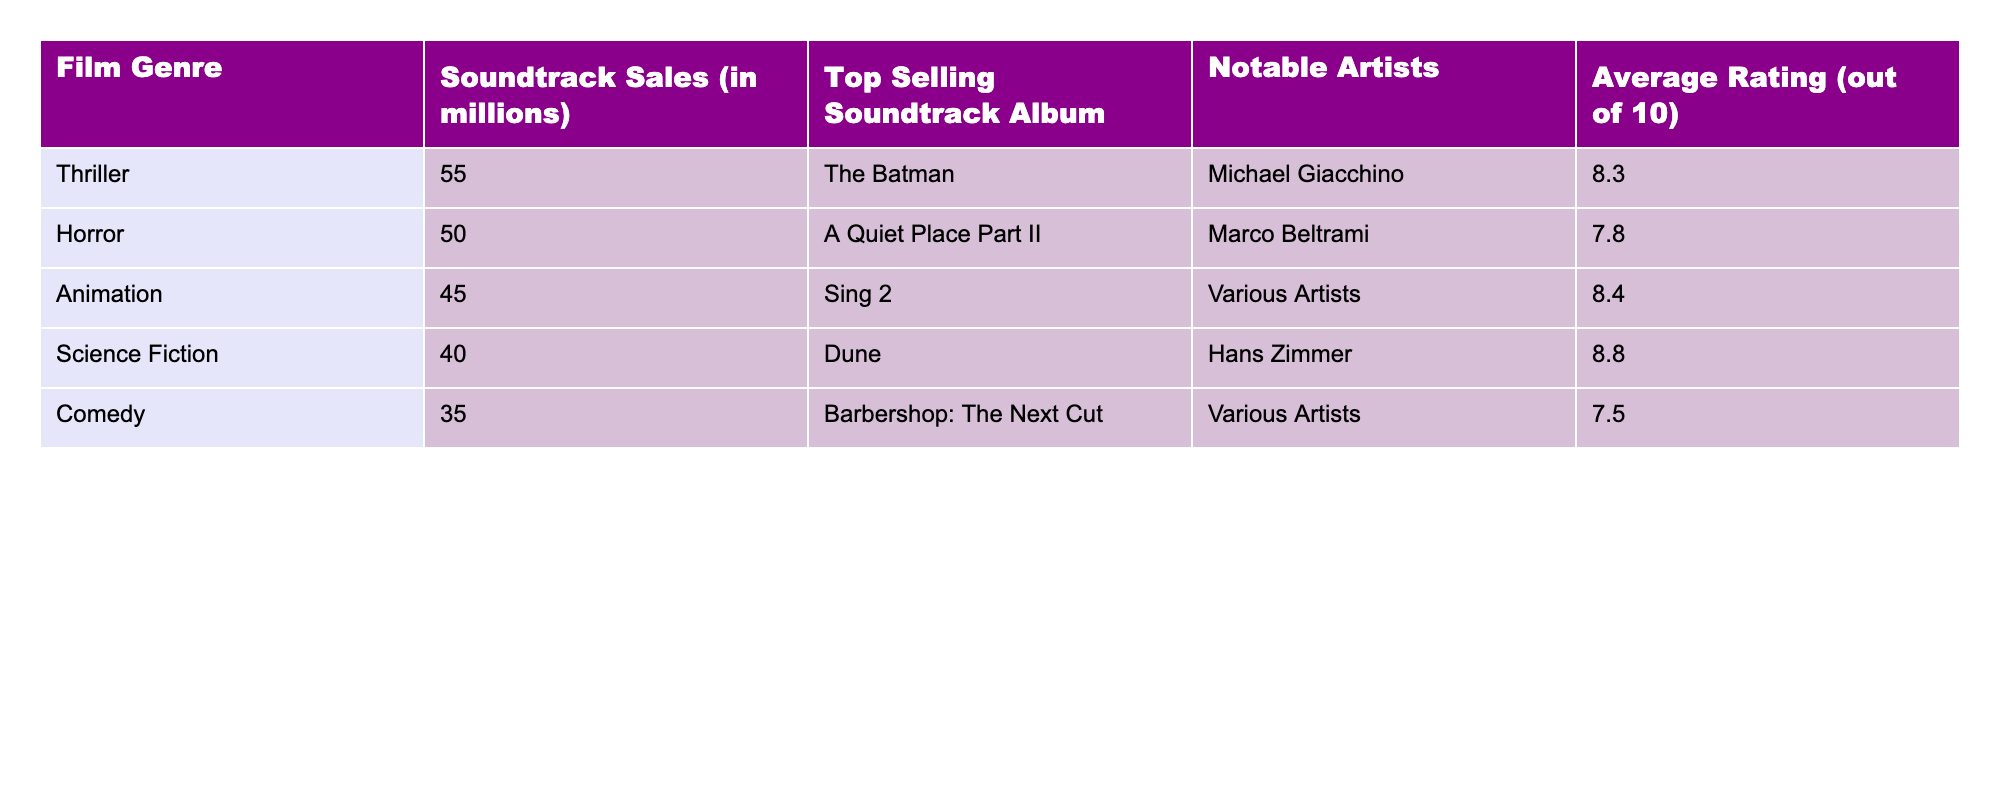What is the top-selling soundtrack album for the Thriller genre? According to the table, "The Batman" is listed as the top-selling soundtrack album for the Thriller genre.
Answer: The Batman What is the average rating of the Animation films? The table shows that the average rating for Animation films is listed as 8.4.
Answer: 8.4 Which genre has the highest soundtrack sales? The table indicates that the Thriller genre has the highest soundtrack sales at 55 million.
Answer: Thriller How much higher are the soundtrack sales for Horror compared to Comedy? To find the difference, we subtract the soundtrack sales of Comedy (35 million) from Horror (50 million). Thus, 50 - 35 = 15 million.
Answer: 15 million Is the average rating for Science Fiction films higher than that of Horror films? The average rating for Science Fiction is 8.8, while for Horror it is 7.8. Since 8.8 is greater than 7.8, the statement is true.
Answer: Yes What is the total soundtrack sales for Animation and Science Fiction genres combined? By adding the soundtrack sales of Animation (45 million) and Science Fiction (40 million), we get 45 + 40 = 85 million.
Answer: 85 million Which notable artist is associated with the top-selling album in the Science Fiction genre? The notable artist for the soundtrack album "Dune," which is the top-seller in the Science Fiction genre, is Hans Zimmer.
Answer: Hans Zimmer What is the average soundtrack sales across all film genres listed? To find the average, we first sum the soundtrack sales: 55 + 50 + 45 + 40 + 35 = 225 million. Then, dividing by the number of genres (5) gives 225 / 5 = 45 million.
Answer: 45 million How does the average rating of the top-selling soundtrack (The Batman) compare to the average rating of the Comedy genre? The average rating for "The Batman" is 8.3, while the average rating for Comedy is 7.5. Since 8.3 is greater than 7.5, the comparison shows that The Batman has a higher rating.
Answer: Higher Which genre has both the lowest soundtrack sales and average rating? By reviewing the table, we see that Comedy has the lowest soundtrack sales (35 million) and an average rating of 7.5, making it the genre with the lowest in both categories.
Answer: Comedy 